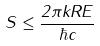Convert formula to latex. <formula><loc_0><loc_0><loc_500><loc_500>S \leq \frac { 2 \pi k R E } { \hbar { c } }</formula> 